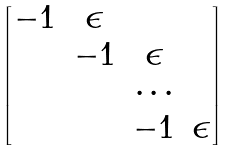<formula> <loc_0><loc_0><loc_500><loc_500>\begin{bmatrix} - 1 & \epsilon & & \\ & - 1 & \epsilon & \\ & & \cdots \\ & & - 1 & \epsilon \end{bmatrix}</formula> 